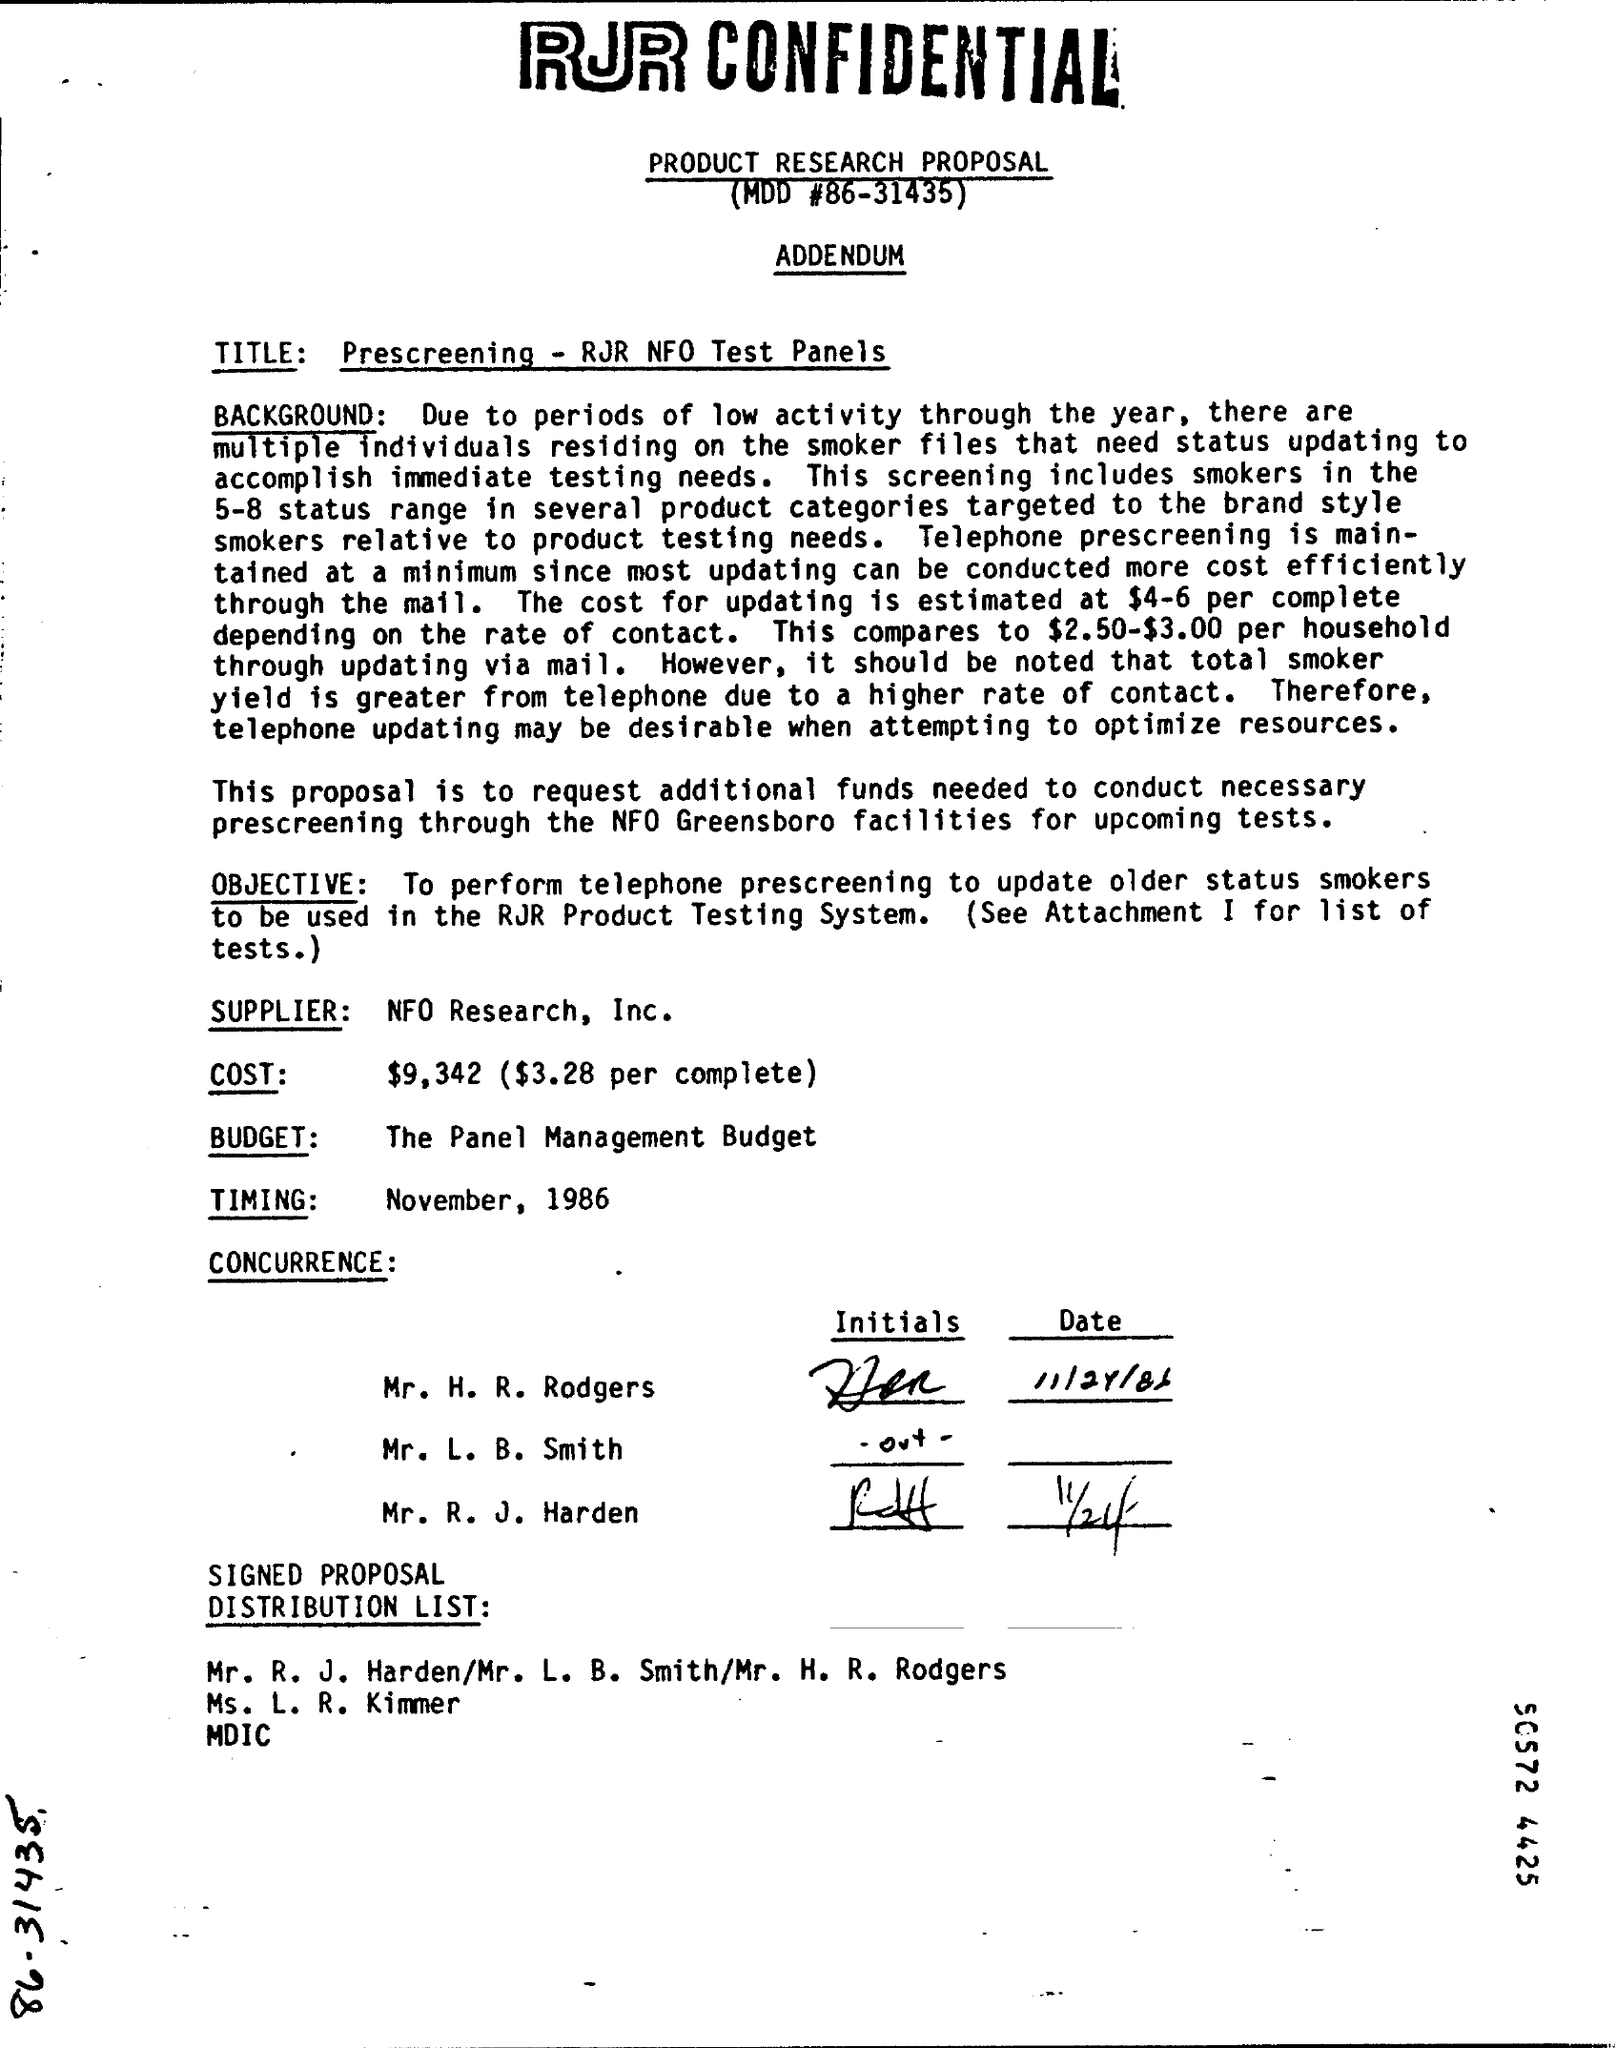Specify some key components in this picture. The date of November, 1986 is the timing of the event. The title of this document is 'Prescreening - RJR NFO Test Panels.' The supplier is NFO Research, Inc. What is MOD #? It is a code used in programming that performs a specific operation on a number. The specific operation depends on the values of the number and a second number known as the modulus. For example, if the modulus is 86, the operation would be to take the number and return the remainder when it is divided by 86. The specific operation for a given modulus and number can be found by using the formula MOD # = (number - remainder) % modulus. The Panel Management Budget is a financial plan outlining the expenses and income for a particular panel or group of panels. 